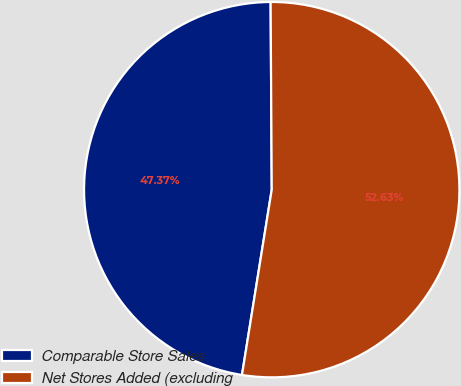<chart> <loc_0><loc_0><loc_500><loc_500><pie_chart><fcel>Comparable Store Sales<fcel>Net Stores Added (excluding<nl><fcel>47.37%<fcel>52.63%<nl></chart> 